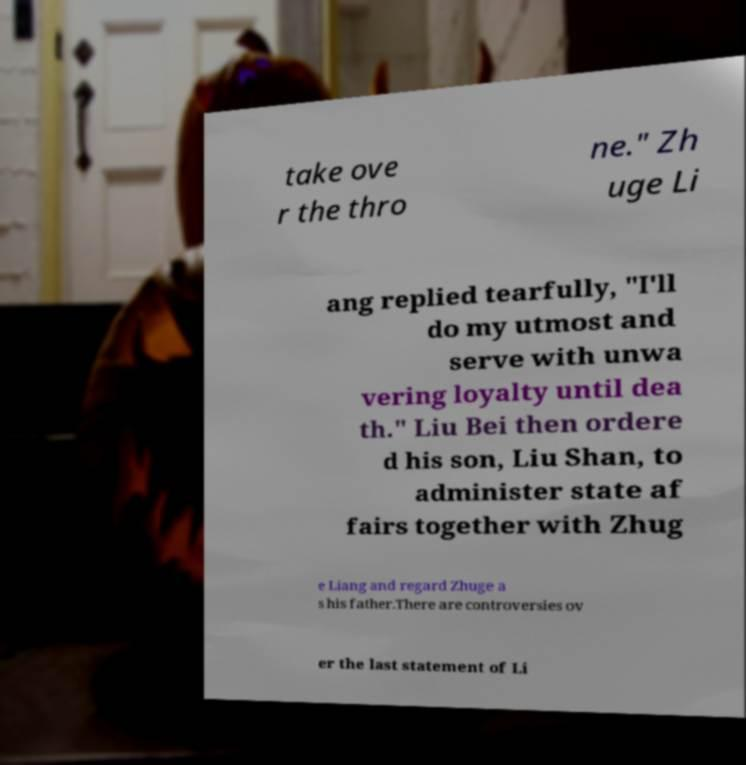I need the written content from this picture converted into text. Can you do that? take ove r the thro ne." Zh uge Li ang replied tearfully, "I'll do my utmost and serve with unwa vering loyalty until dea th." Liu Bei then ordere d his son, Liu Shan, to administer state af fairs together with Zhug e Liang and regard Zhuge a s his father.There are controversies ov er the last statement of Li 